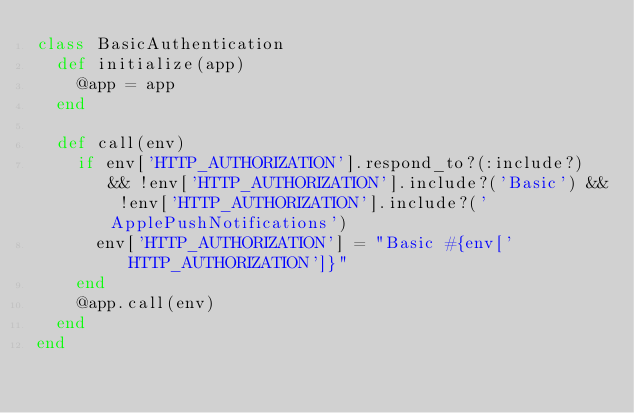Convert code to text. <code><loc_0><loc_0><loc_500><loc_500><_Ruby_>class BasicAuthentication
  def initialize(app)
    @app = app
  end

  def call(env)
    if env['HTTP_AUTHORIZATION'].respond_to?(:include?) && !env['HTTP_AUTHORIZATION'].include?('Basic') && !env['HTTP_AUTHORIZATION'].include?('ApplePushNotifications')
      env['HTTP_AUTHORIZATION'] = "Basic #{env['HTTP_AUTHORIZATION']}"
    end
    @app.call(env)
  end
end</code> 